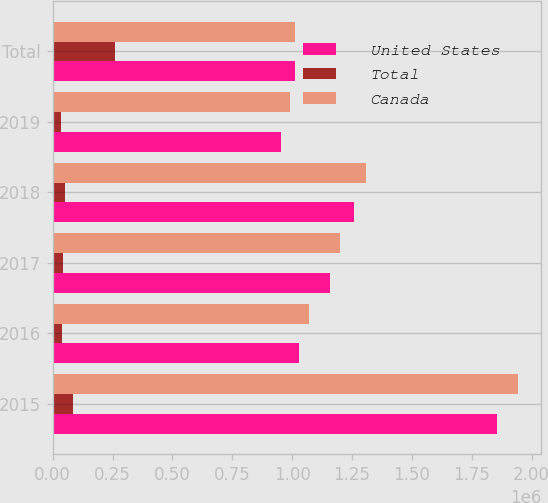Convert chart. <chart><loc_0><loc_0><loc_500><loc_500><stacked_bar_chart><ecel><fcel>2015<fcel>2016<fcel>2017<fcel>2018<fcel>2019<fcel>Total<nl><fcel>United States<fcel>1.8561e+06<fcel>1.02908e+06<fcel>1.15589e+06<fcel>1.2597e+06<fcel>953581<fcel>1.00967e+06<nl><fcel>Total<fcel>86518<fcel>40378<fcel>45041<fcel>50243<fcel>36679<fcel>258859<nl><fcel>Canada<fcel>1.94262e+06<fcel>1.06945e+06<fcel>1.20093e+06<fcel>1.30994e+06<fcel>990260<fcel>1.00967e+06<nl></chart> 